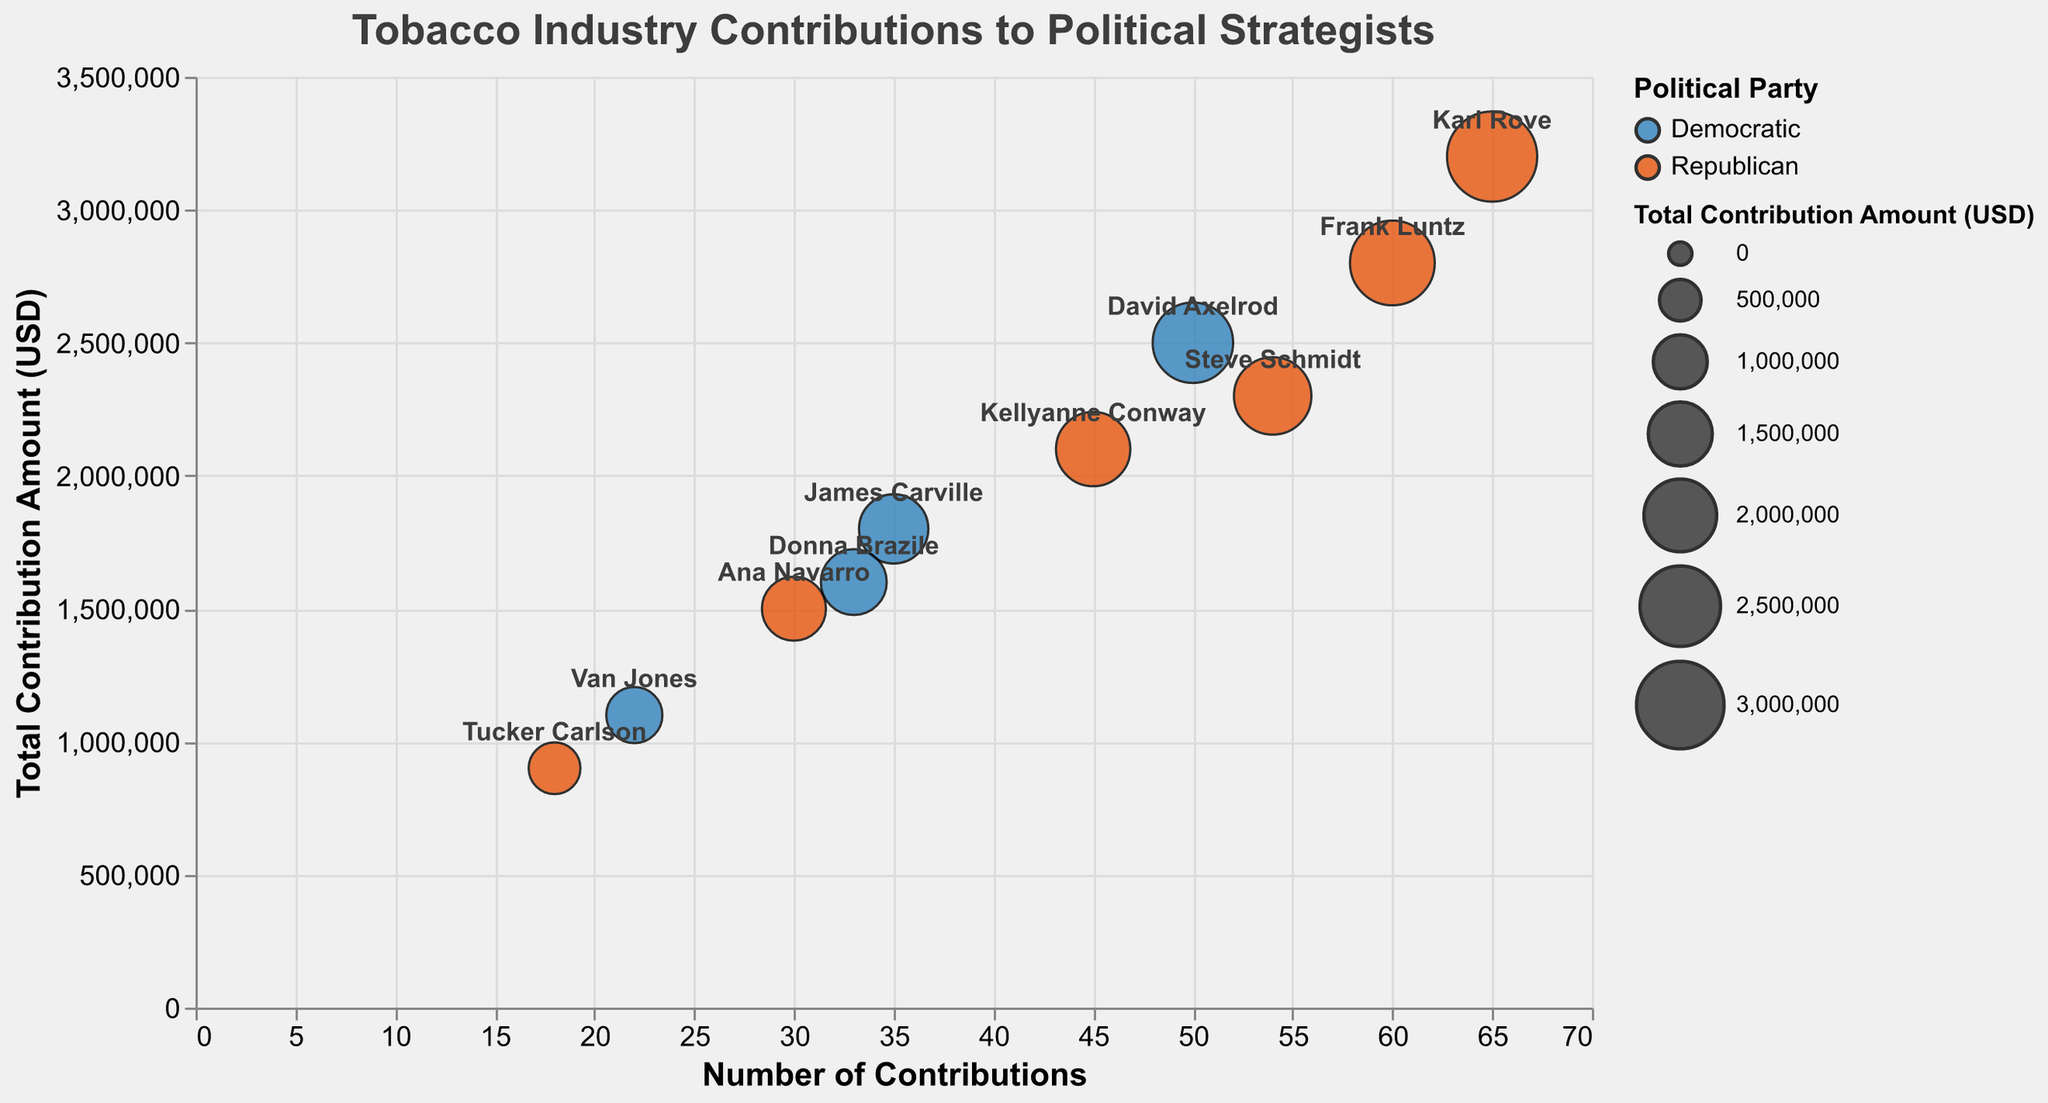What is the title of the chart? The chart title is commonly displayed at the top and serves as an introductory descriptor of the data visualization. It helps viewers understand what the chart is about at first glance. The title of this chart is "Tobacco Industry Contributions to Political Strategists."
Answer: Tobacco Industry Contributions to Political Strategists How many strategists are affiliated with the Republican party? By looking at the color of the bubbles (orange) representing the Republican party on the chart, count the number of such bubbles; this corresponds to the number of Republican-affiliated strategists. There are 6 orange bubbles representing Republican strategists.
Answer: 6 Which political strategist received the highest total contribution amount from the tobacco industry? Look at the y-axis representing the total contribution amount; the bubble highest up on this axis corresponds to the strategist with the highest total contribution. Karl Rove is at the highest position along the y-axis with a total contribution amount of 3,200,000 USD.
Answer: Karl Rove What is the range of the number of contributions for all political strategists? Check the smallest and largest values on the x-axis representing the number of contributions. The smallest value is 18, and the largest value is 65. The range is the difference between these two values.
Answer: 18-65 What is the total number of contributions received by Democratic strategists? Sum the number of contributions for all bubbles representing Democratic strategists (blue bubbles), which are for David Axelrod, James Carville, Donna Brazile, and Van Jones. The contributions are 50, 35, 33, and 22, respectively. Adding these gives 50 + 35 + 33 + 22 = 140 contributions.
Answer: 140 For which political strategist is the number of contributions closest to the average number of contributions across all strategists? Calculate the average number of contributions first by summing all contributions and dividing by the total number of strategists. The total number of contributions is 50 + 65 + 35 + 45 + 54 + 30 + 33 + 60 + 22 + 18 = 412. The average is 412 / 10 = 41.2. Identify the strategist whose number of contributions is closest to 41.2. Kellyanne Conway has 45 contributions, which is closest to the average.
Answer: Kellyanne Conway Which strategist from the Democratic party had the lowest total contribution amount, and what was that amount? Locate the blue bubbles and identify the one with the lowest position on the y-axis. Van Jones, among Democratic strategists, has the lowest total contribution at 1,100,000 USD.
Answer: Van Jones, 1,100,000 USD Comparing Donna Brazile and Steve Schmidt, who received more from the tobacco industry, and by how much? Look for the bubbles representing Donna Brazile (blue) and Steve Schmidt (orange). Check their respective positions on the y-axis to determine the total contribution amount. Donna Brazile received 1,600,000 USD; Steve Schmidt received 2,300,000 USD. The difference is 2,300,000 - 1,600,000 = 700,000 USD.
Answer: Steve Schmidt by 700,000 USD Which political strategist has the largest bubble size, and what does it represent? Look for the largest bubble on the chart, which is indicative of a larger total contribution amount. Karl Rove has the largest bubble, representing the largest total contribution amount of 3,200,000 USD.
Answer: Karl Rove, total contribution amount 